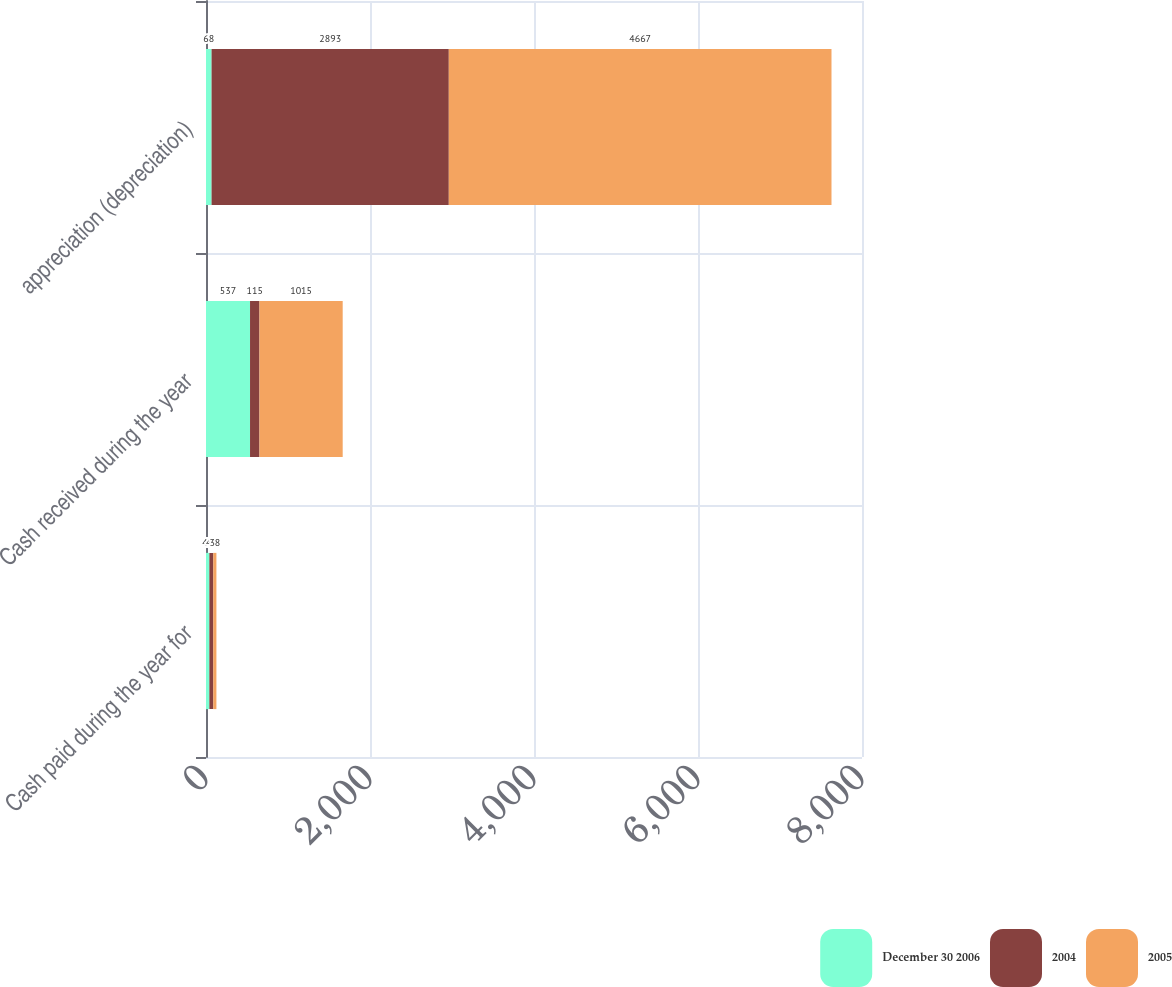Convert chart to OTSL. <chart><loc_0><loc_0><loc_500><loc_500><stacked_bar_chart><ecel><fcel>Cash paid during the year for<fcel>Cash received during the year<fcel>appreciation (depreciation)<nl><fcel>December 30 2006<fcel>41<fcel>537<fcel>68<nl><fcel>2004<fcel>48<fcel>115<fcel>2893<nl><fcel>2005<fcel>38<fcel>1015<fcel>4667<nl></chart> 